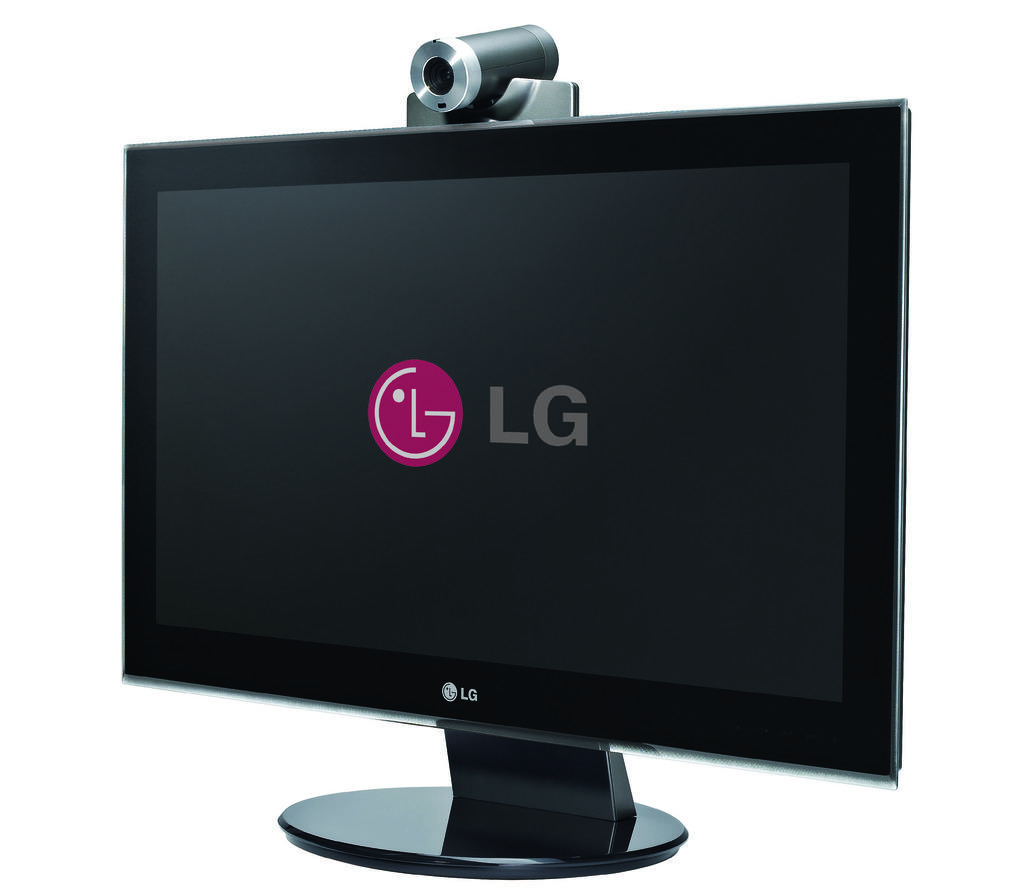Who makes this screen?
Give a very brief answer. Lg. 